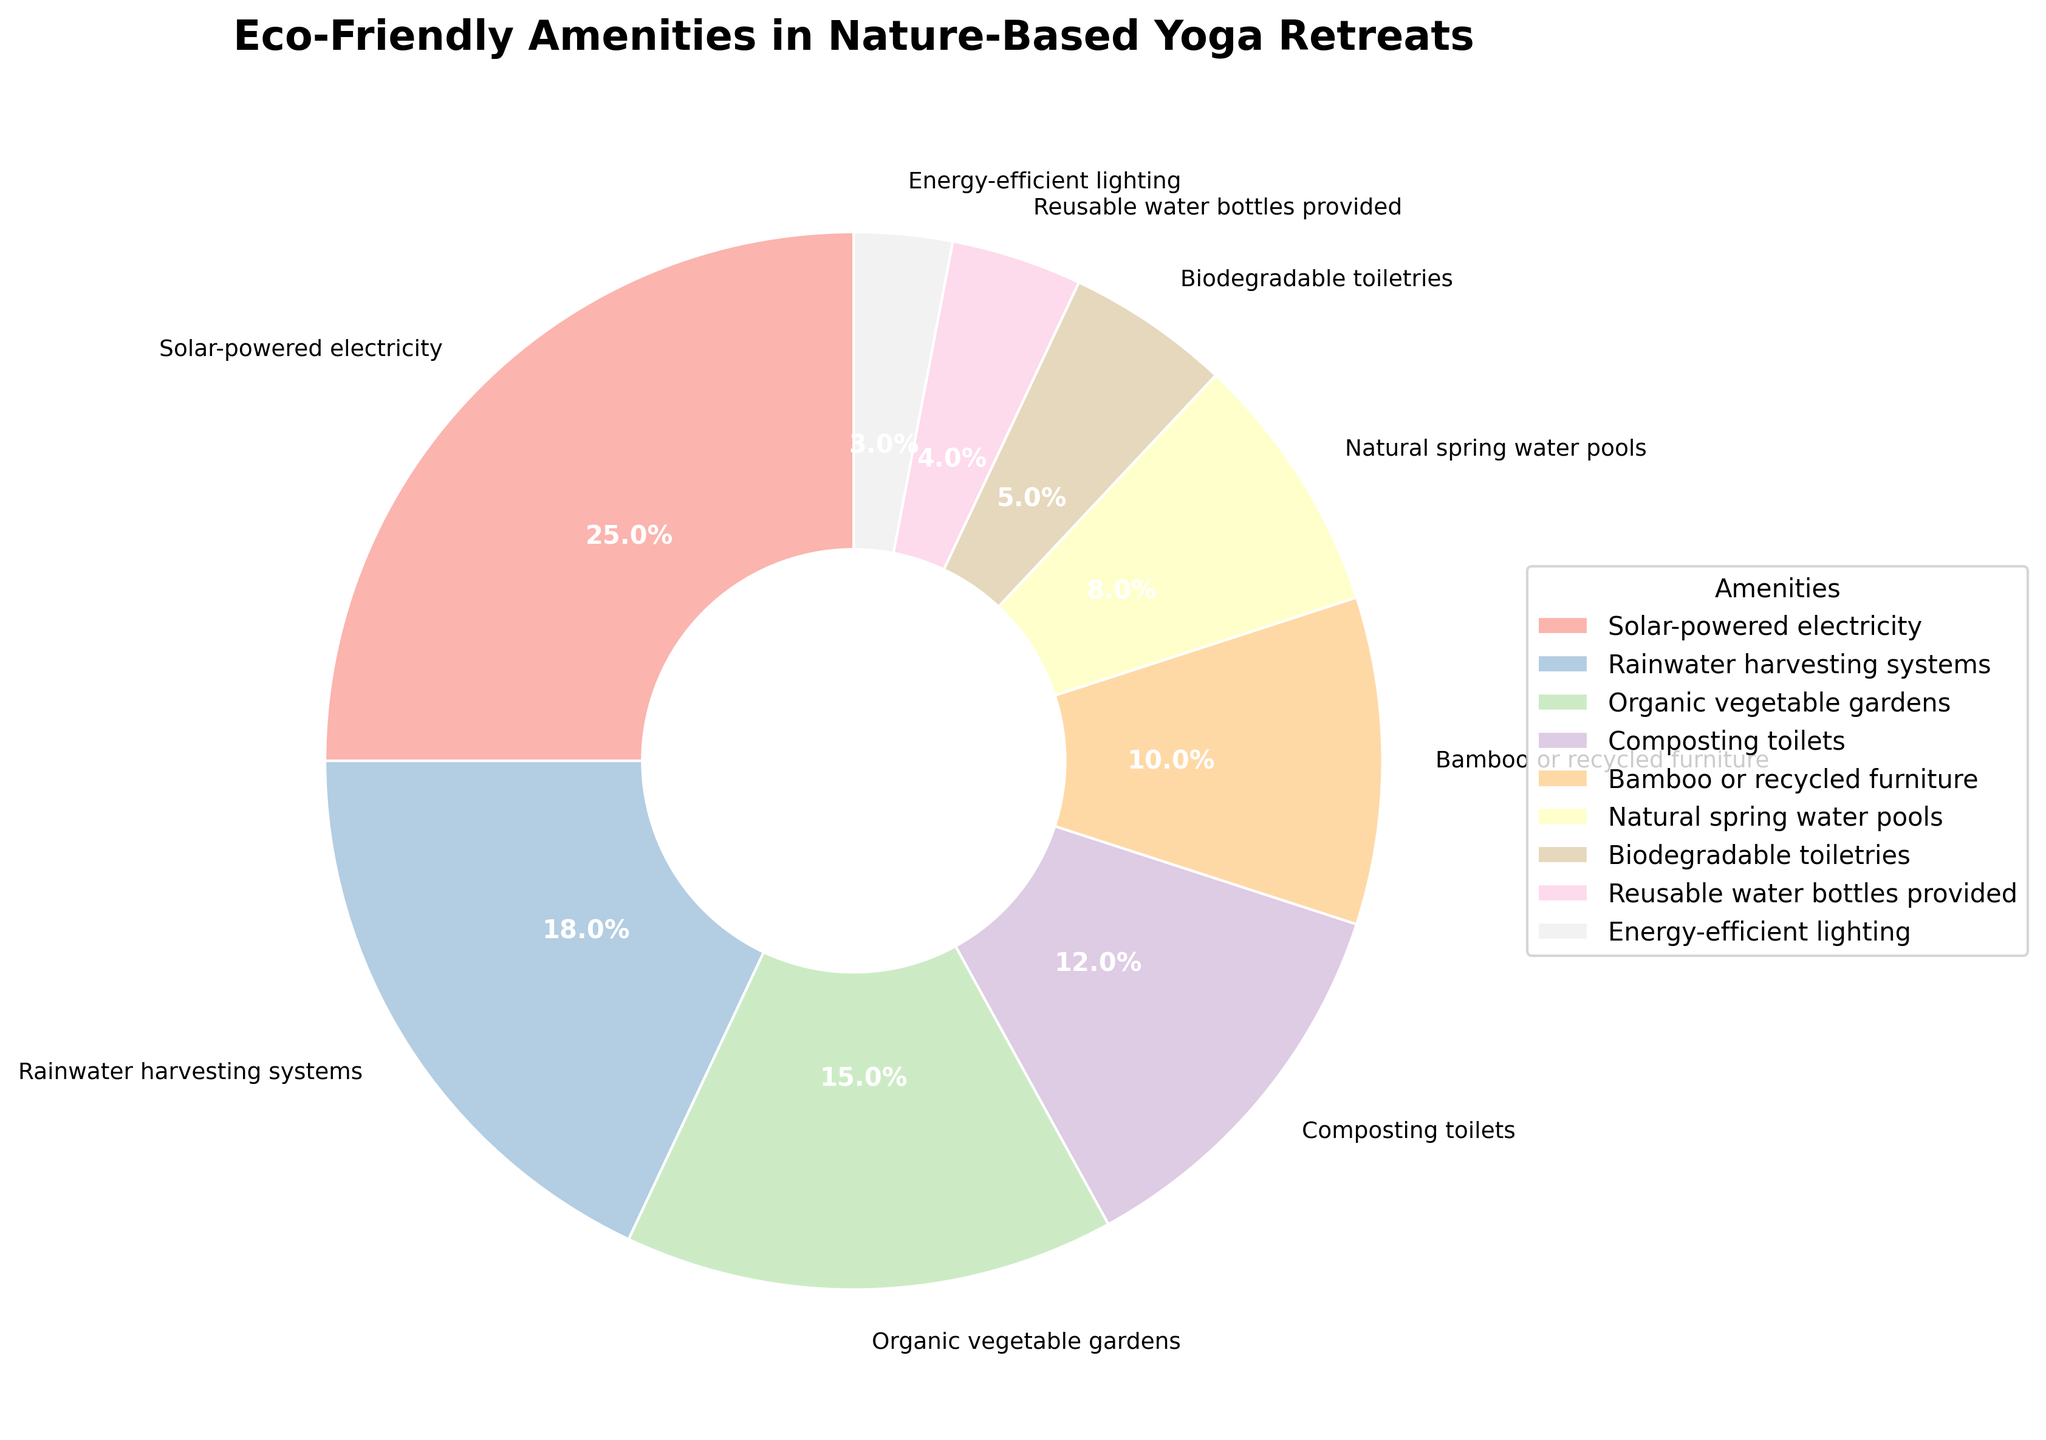Which eco-friendly amenity has the highest percentage? By looking at the pie chart, the segment with the largest size represents the amenity with the highest percentage. The largest segment corresponds to Solar-powered electricity.
Answer: Solar-powered electricity Which amenity has the lowest percentage? The segment with the smallest size represents the least common amenity. This segment corresponds to Reusable water bottles provided.
Answer: Reusable water bottles provided What is the combined percentage of Organic vegetable gardens and Natural spring water pools? The percentage of Organic vegetable gardens is 15%, and the percentage of Natural spring water pools is 8%. Adding these together gives 15% + 8% = 23%.
Answer: 23% Between Rainwater harvesting systems and Composting toilets, which has a higher percentage and by how much? Rainwater harvesting systems have an 18% share, while Composting toilets have a 12% share. The difference is 18% - 12% = 6%.
Answer: Rainwater harvesting systems, 6% What percentage do Bamboo or recycled furniture and Biodegradable toiletries contribute together, and is it greater than Organic vegetable gardens alone? Bamboo or recycled furniture contribute 10%, and Biodegradable toiletries contribute 5%. Together, they make 10% + 5% = 15%. Organic vegetable gardens alone is also 15%. The combined percentage is equal to Organic vegetable gardens.
Answer: 15%, equal Which amenities have a combined percentage greater than 30%? By evaluating combinations: Solar-powered electricity (25%) and Rainwater harvesting systems (18%) together make 43%, which is greater than 30%. Any other combination results in a percentage higher than 30% if one element is included.
Answer: Solar-powered electricity and Rainwater harvesting systems How much greater is the percentage of Solar-powered electricity compared to Energy-efficient lighting? Solar-powered electricity is at 25%, while Energy-efficient lighting is at 3%. The difference is 25% - 3% = 22%.
Answer: 22% Do Composting toilets and Bamboo or recycled furniture combined have a higher percentage than Solar-powered electricity alone? Composting toilets are 12%, and Bamboo or recycled furniture are 10%. Combined, they are 12% + 10% = 22%, which is less than Solar-powered electricity at 25%.
Answer: No If the combined percentage of Energy-efficient lighting and Reusable water bottles provided was increased by 5%, what would the new total be? Energy-efficient lighting is 3%, and Reusable water bottles provided are 4%. Combined, they are 3% + 4% = 7%. Increasing by 5%, the new total would be 7% + 5% = 12%.
Answer: 12% Which amenities have percentages less than 10%? From the pie chart, the amenities with segments smaller than 10% are Natural spring water pools (8%), Biodegradable toiletries (5%), Reusable water bottles provided (4%), and Energy-efficient lighting (3%).
Answer: Natural spring water pools, Biodegradable toiletries, Reusable water bottles provided, Energy-efficient lighting 